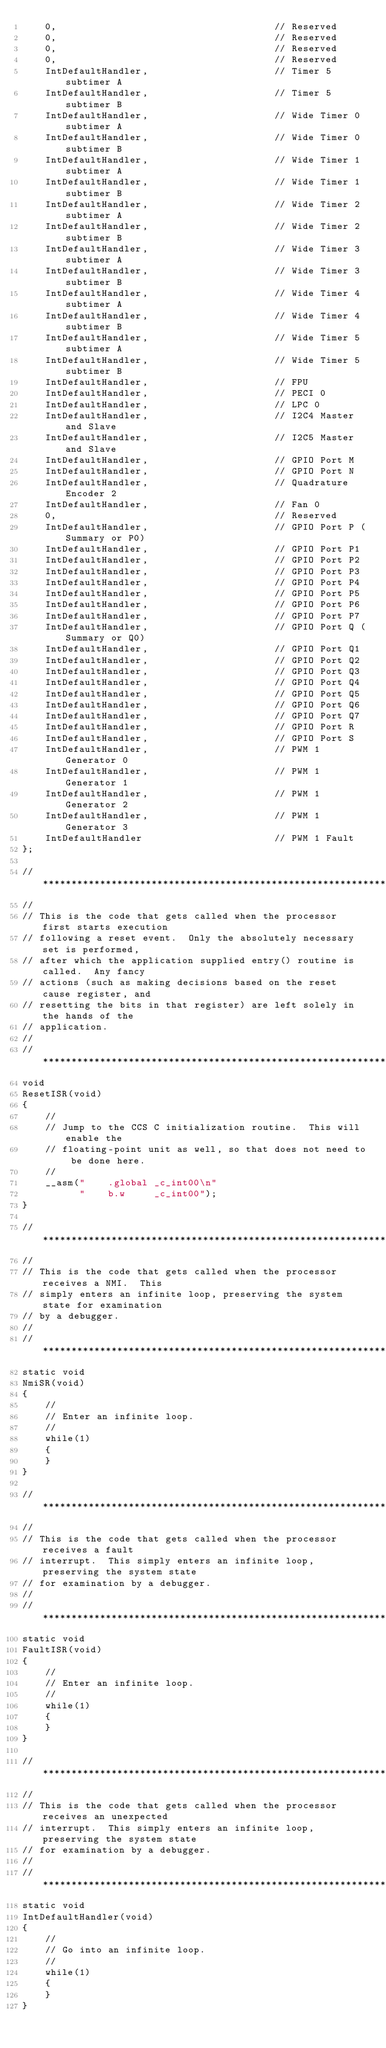Convert code to text. <code><loc_0><loc_0><loc_500><loc_500><_C_>    0,                                      // Reserved
    0,                                      // Reserved
    0,                                      // Reserved
    0,                                      // Reserved
    IntDefaultHandler,                      // Timer 5 subtimer A
    IntDefaultHandler,                      // Timer 5 subtimer B
    IntDefaultHandler,                      // Wide Timer 0 subtimer A
    IntDefaultHandler,                      // Wide Timer 0 subtimer B
    IntDefaultHandler,                      // Wide Timer 1 subtimer A
    IntDefaultHandler,                      // Wide Timer 1 subtimer B
    IntDefaultHandler,                      // Wide Timer 2 subtimer A
    IntDefaultHandler,                      // Wide Timer 2 subtimer B
    IntDefaultHandler,                      // Wide Timer 3 subtimer A
    IntDefaultHandler,                      // Wide Timer 3 subtimer B
    IntDefaultHandler,                      // Wide Timer 4 subtimer A
    IntDefaultHandler,                      // Wide Timer 4 subtimer B
    IntDefaultHandler,                      // Wide Timer 5 subtimer A
    IntDefaultHandler,                      // Wide Timer 5 subtimer B
    IntDefaultHandler,                      // FPU
    IntDefaultHandler,                      // PECI 0
    IntDefaultHandler,                      // LPC 0
    IntDefaultHandler,                      // I2C4 Master and Slave
    IntDefaultHandler,                      // I2C5 Master and Slave
    IntDefaultHandler,                      // GPIO Port M
    IntDefaultHandler,                      // GPIO Port N
    IntDefaultHandler,                      // Quadrature Encoder 2
    IntDefaultHandler,                      // Fan 0
    0,                                      // Reserved
    IntDefaultHandler,                      // GPIO Port P (Summary or P0)
    IntDefaultHandler,                      // GPIO Port P1
    IntDefaultHandler,                      // GPIO Port P2
    IntDefaultHandler,                      // GPIO Port P3
    IntDefaultHandler,                      // GPIO Port P4
    IntDefaultHandler,                      // GPIO Port P5
    IntDefaultHandler,                      // GPIO Port P6
    IntDefaultHandler,                      // GPIO Port P7
    IntDefaultHandler,                      // GPIO Port Q (Summary or Q0)
    IntDefaultHandler,                      // GPIO Port Q1
    IntDefaultHandler,                      // GPIO Port Q2
    IntDefaultHandler,                      // GPIO Port Q3
    IntDefaultHandler,                      // GPIO Port Q4
    IntDefaultHandler,                      // GPIO Port Q5
    IntDefaultHandler,                      // GPIO Port Q6
    IntDefaultHandler,                      // GPIO Port Q7
    IntDefaultHandler,                      // GPIO Port R
    IntDefaultHandler,                      // GPIO Port S
    IntDefaultHandler,                      // PWM 1 Generator 0
    IntDefaultHandler,                      // PWM 1 Generator 1
    IntDefaultHandler,                      // PWM 1 Generator 2
    IntDefaultHandler,                      // PWM 1 Generator 3
    IntDefaultHandler                       // PWM 1 Fault
};

//*****************************************************************************
//
// This is the code that gets called when the processor first starts execution
// following a reset event.  Only the absolutely necessary set is performed,
// after which the application supplied entry() routine is called.  Any fancy
// actions (such as making decisions based on the reset cause register, and
// resetting the bits in that register) are left solely in the hands of the
// application.
//
//*****************************************************************************
void
ResetISR(void)
{
    //
    // Jump to the CCS C initialization routine.  This will enable the
    // floating-point unit as well, so that does not need to be done here.
    //
    __asm("    .global _c_int00\n"
          "    b.w     _c_int00");
}

//*****************************************************************************
//
// This is the code that gets called when the processor receives a NMI.  This
// simply enters an infinite loop, preserving the system state for examination
// by a debugger.
//
//*****************************************************************************
static void
NmiSR(void)
{
    //
    // Enter an infinite loop.
    //
    while(1)
    {
    }
}

//*****************************************************************************
//
// This is the code that gets called when the processor receives a fault
// interrupt.  This simply enters an infinite loop, preserving the system state
// for examination by a debugger.
//
//*****************************************************************************
static void
FaultISR(void)
{
    //
    // Enter an infinite loop.
    //
    while(1)
    {
    }
}

//*****************************************************************************
//
// This is the code that gets called when the processor receives an unexpected
// interrupt.  This simply enters an infinite loop, preserving the system state
// for examination by a debugger.
//
//*****************************************************************************
static void
IntDefaultHandler(void)
{
    //
    // Go into an infinite loop.
    //
    while(1)
    {
    }
}
</code> 